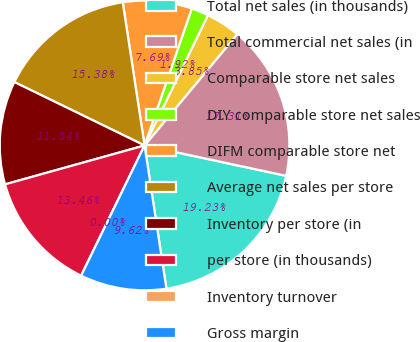Convert chart. <chart><loc_0><loc_0><loc_500><loc_500><pie_chart><fcel>Total net sales (in thousands)<fcel>Total commercial net sales (in<fcel>Comparable store net sales<fcel>DIY comparable store net sales<fcel>DIFM comparable store net<fcel>Average net sales per store<fcel>Inventory per store (in<fcel>per store (in thousands)<fcel>Inventory turnover<fcel>Gross margin<nl><fcel>19.23%<fcel>17.31%<fcel>3.85%<fcel>1.92%<fcel>7.69%<fcel>15.38%<fcel>11.54%<fcel>13.46%<fcel>0.0%<fcel>9.62%<nl></chart> 